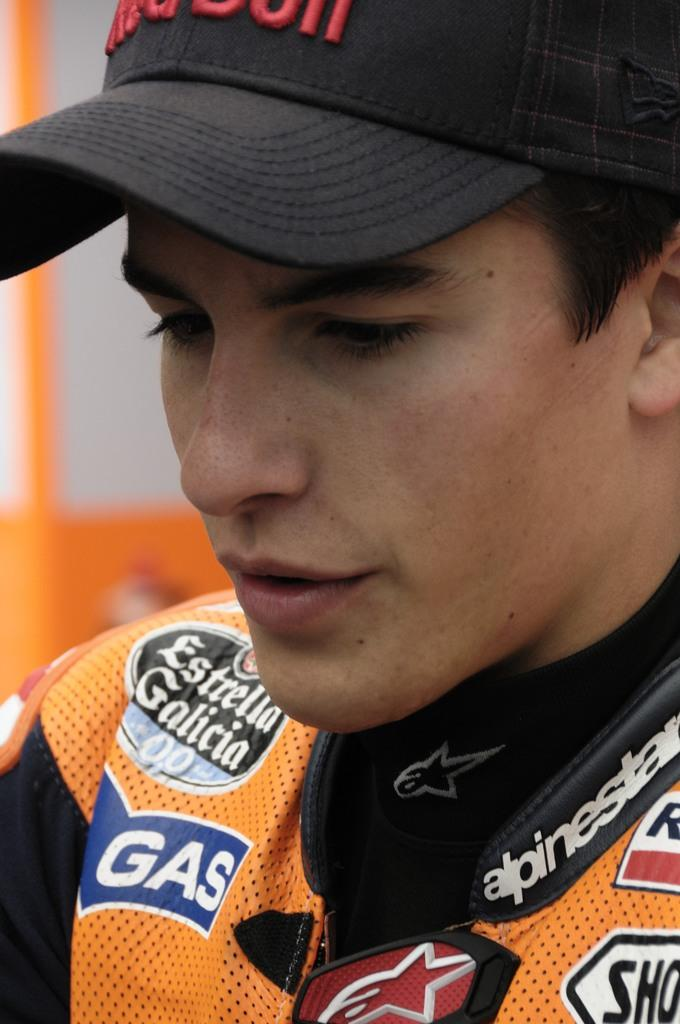<image>
Write a terse but informative summary of the picture. A man wears a jacket with many logos, including Estrella Galicia. 